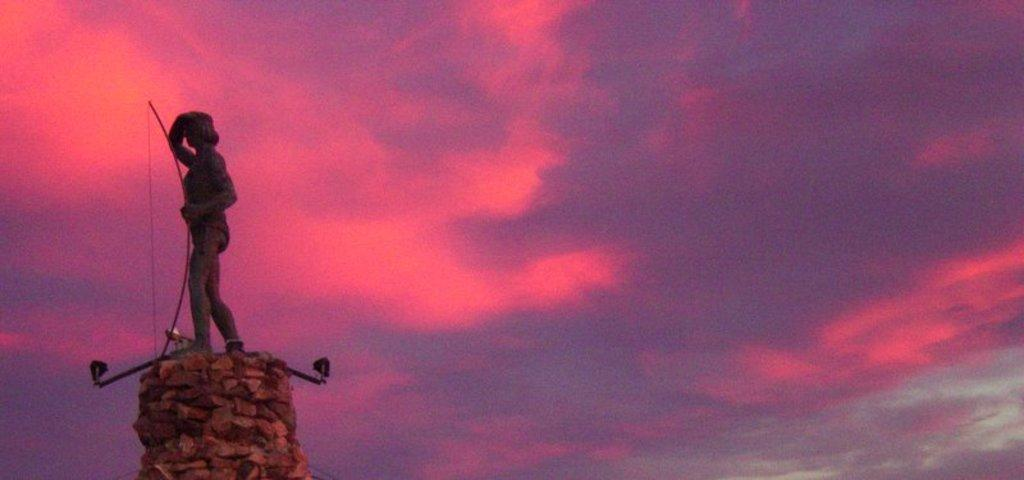What is the main subject of the image? There is a statue in the image. Where is the statue located? The statue is on a rock. What colors can be seen in the background of the image? The background of the image has pink, purple, and white colors. Can you tell me how many umbrellas are open in the image? There are no umbrellas present in the image. What type of owl can be seen perched on the statue's head in the image? There is no owl present on the statue's head in the image. 